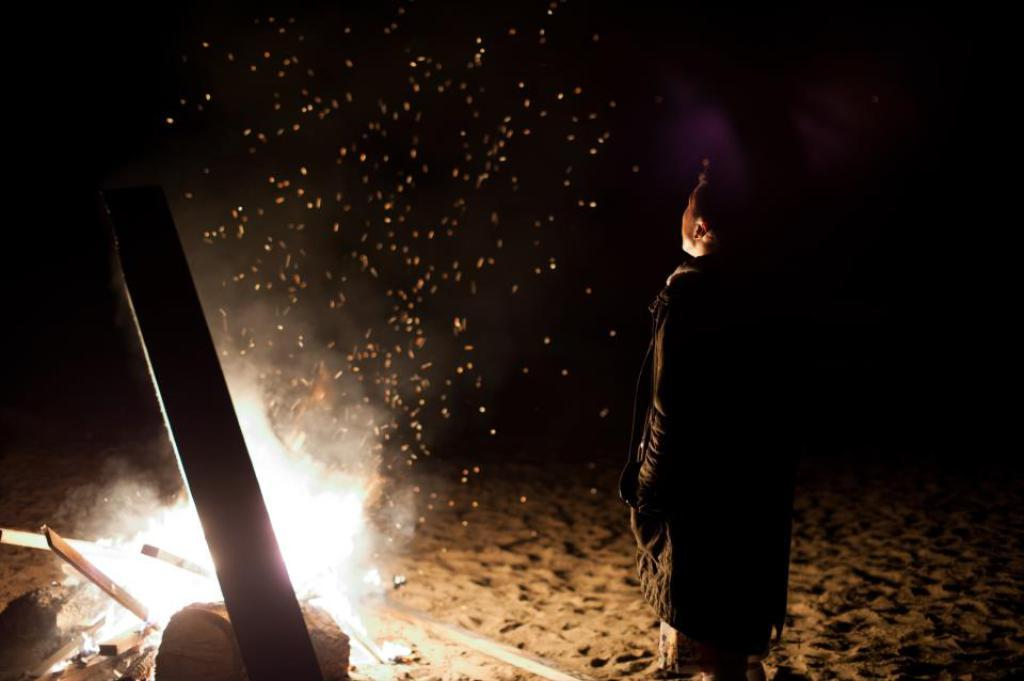What is the main subject of the image? There is a person in the image. What type of terrain is the person standing on? The person is standing on sandy land. What can be seen in front of the person? There is a campfire in front of the person. Can you tell me how many jars of marshmallows are being used to smile at the campfire? There is no mention of jars of marshmallows or any smiling objects in the image; it simply features a person standing near a campfire. 